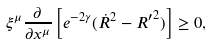Convert formula to latex. <formula><loc_0><loc_0><loc_500><loc_500>\xi ^ { \mu } \frac { \partial } { \partial x ^ { \mu } } \left [ e ^ { - 2 \gamma } ( \dot { R } ^ { 2 } - { R ^ { \prime } } ^ { 2 } ) \right ] \geq 0 ,</formula> 